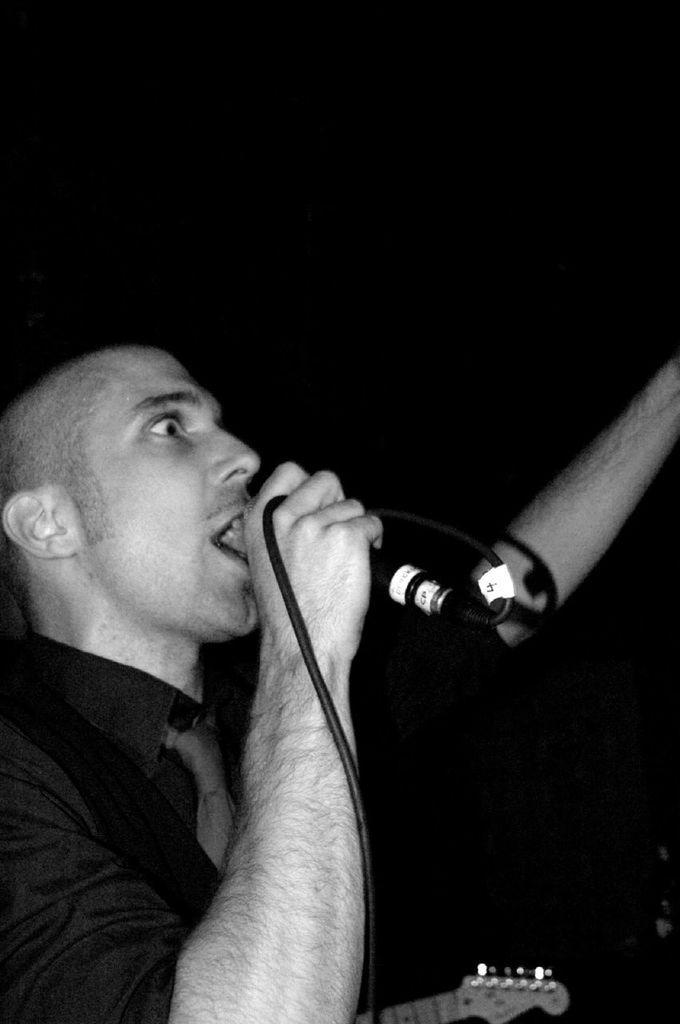Describe this image in one or two sentences. In this picture there is a boy who is standing at the left side of the image by holding a mic and guitar in his hand, the color of the background is black. 